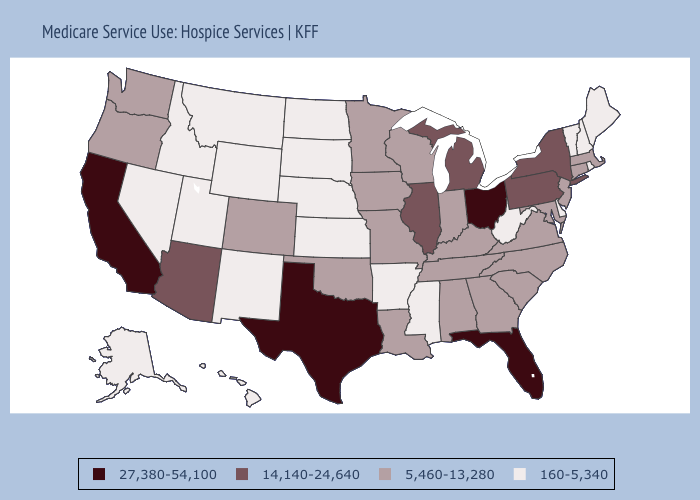What is the value of Mississippi?
Be succinct. 160-5,340. Does Tennessee have a lower value than Ohio?
Keep it brief. Yes. What is the lowest value in the USA?
Answer briefly. 160-5,340. What is the lowest value in the Northeast?
Short answer required. 160-5,340. Does Oregon have a lower value than Alabama?
Give a very brief answer. No. What is the value of Colorado?
Answer briefly. 5,460-13,280. What is the highest value in the USA?
Keep it brief. 27,380-54,100. Does New Jersey have the same value as Colorado?
Write a very short answer. Yes. Name the states that have a value in the range 14,140-24,640?
Quick response, please. Arizona, Illinois, Michigan, New York, Pennsylvania. Name the states that have a value in the range 14,140-24,640?
Quick response, please. Arizona, Illinois, Michigan, New York, Pennsylvania. What is the value of Mississippi?
Keep it brief. 160-5,340. Which states have the lowest value in the USA?
Concise answer only. Alaska, Arkansas, Delaware, Hawaii, Idaho, Kansas, Maine, Mississippi, Montana, Nebraska, Nevada, New Hampshire, New Mexico, North Dakota, Rhode Island, South Dakota, Utah, Vermont, West Virginia, Wyoming. Among the states that border North Dakota , which have the highest value?
Give a very brief answer. Minnesota. Name the states that have a value in the range 14,140-24,640?
Keep it brief. Arizona, Illinois, Michigan, New York, Pennsylvania. Does California have a higher value than Florida?
Short answer required. No. 